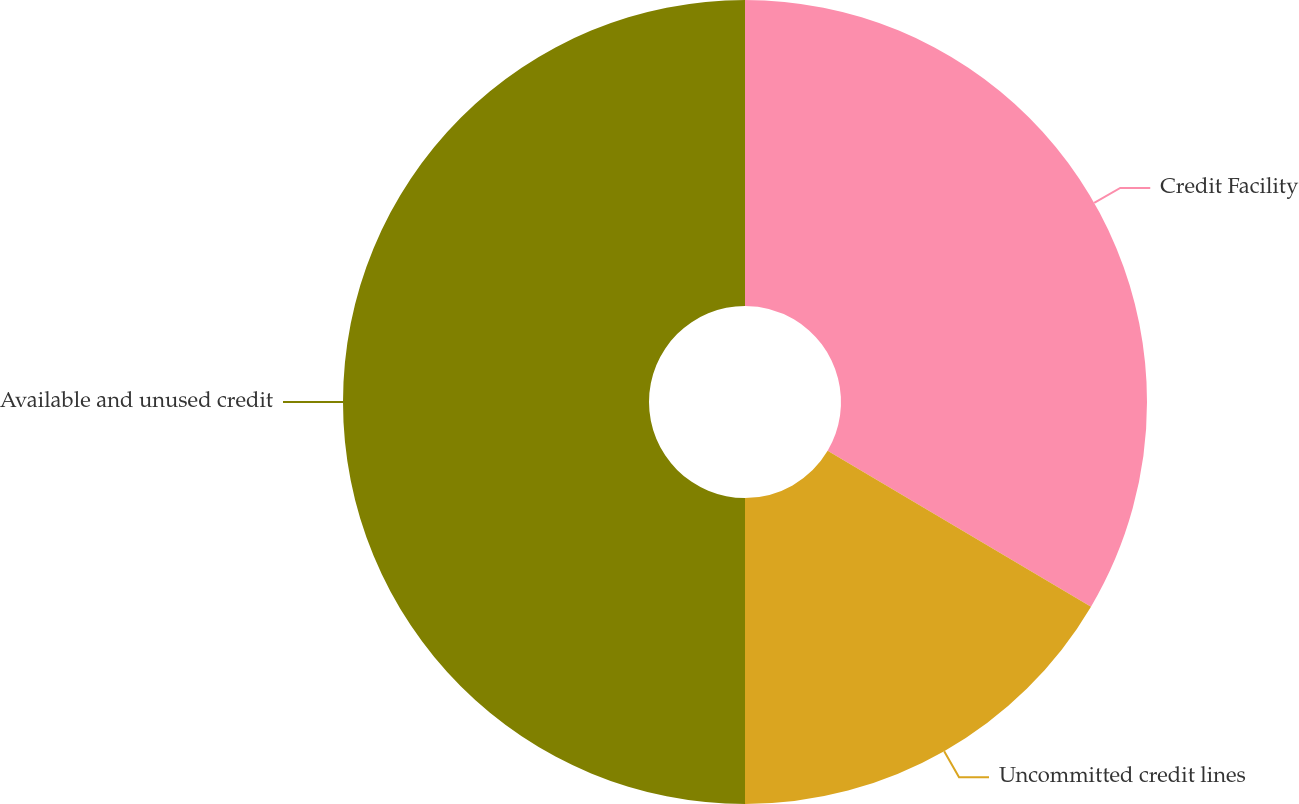<chart> <loc_0><loc_0><loc_500><loc_500><pie_chart><fcel>Credit Facility<fcel>Uncommitted credit lines<fcel>Available and unused credit<nl><fcel>33.5%<fcel>16.5%<fcel>50.0%<nl></chart> 